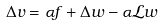Convert formula to latex. <formula><loc_0><loc_0><loc_500><loc_500>\Delta v = \alpha f + \Delta w - \alpha \mathcal { L } w</formula> 